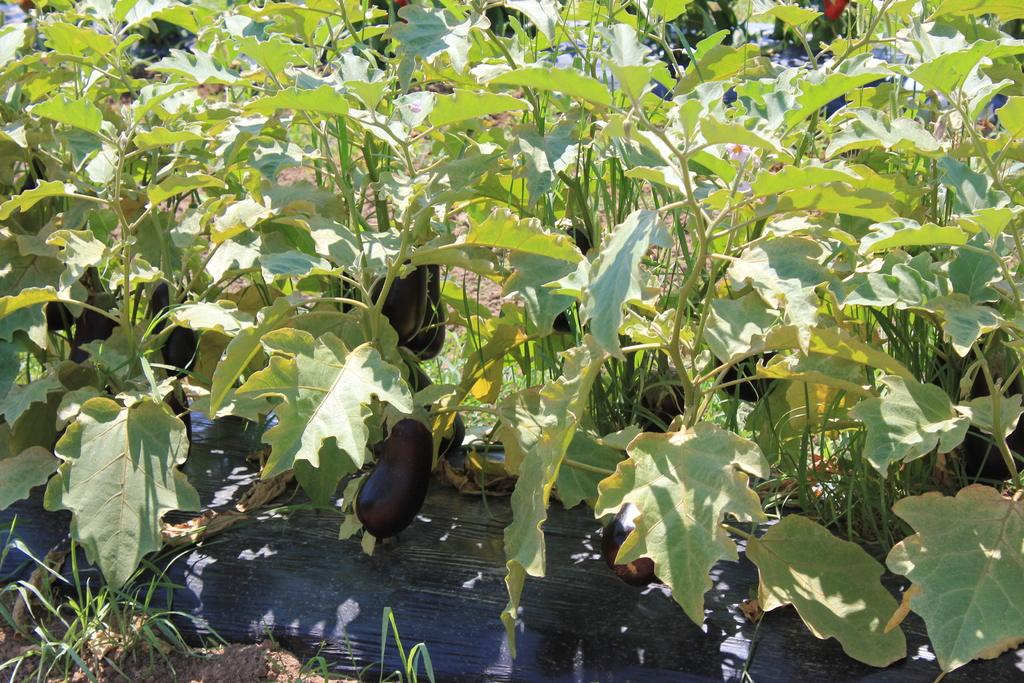What type of plants are in the image? There are brinjal plants in the image. What are the brinjal plants producing? The brinjal plants have brinjals on them. Where are the plants and brinjals located? The plants and brinjals are on the ground. What can be seen covering parts of the ground in the image? There is a cover on the ground at the bottom of the image and in the background at the top of the image. Can you see a camera capturing the brinjal plants in the image? There is no camera visible in the image; it only shows brinjal plants, brinjals, and covers on the ground. 